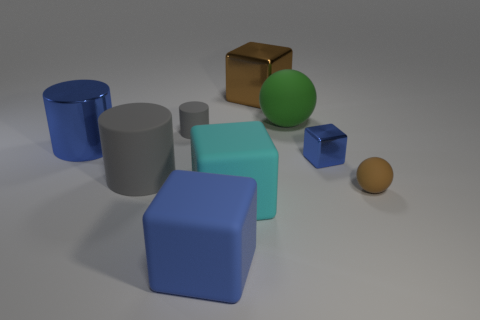What number of other tiny objects are the same shape as the green object?
Provide a succinct answer. 1. There is a blue cube right of the large matte object that is in front of the big rubber block that is right of the large blue block; what size is it?
Your answer should be compact. Small. Is the number of big brown blocks that are to the left of the blue cylinder greater than the number of shiny cylinders?
Your response must be concise. No. Are any small cyan rubber things visible?
Your answer should be compact. No. How many green rubber balls are the same size as the cyan cube?
Ensure brevity in your answer.  1. Are there more small brown objects that are behind the brown shiny thing than big blue cubes that are behind the big gray matte thing?
Offer a very short reply. No. There is a blue cylinder that is the same size as the cyan rubber cube; what material is it?
Your response must be concise. Metal. The big cyan thing has what shape?
Your answer should be compact. Cube. What number of blue things are either large shiny cylinders or big shiny blocks?
Ensure brevity in your answer.  1. What is the size of the cyan block that is the same material as the small cylinder?
Offer a terse response. Large. 